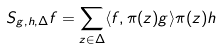Convert formula to latex. <formula><loc_0><loc_0><loc_500><loc_500>S _ { g , h , \Delta } f = \sum _ { z \in \Delta } \langle f , \pi ( z ) g \rangle \pi ( z ) h</formula> 